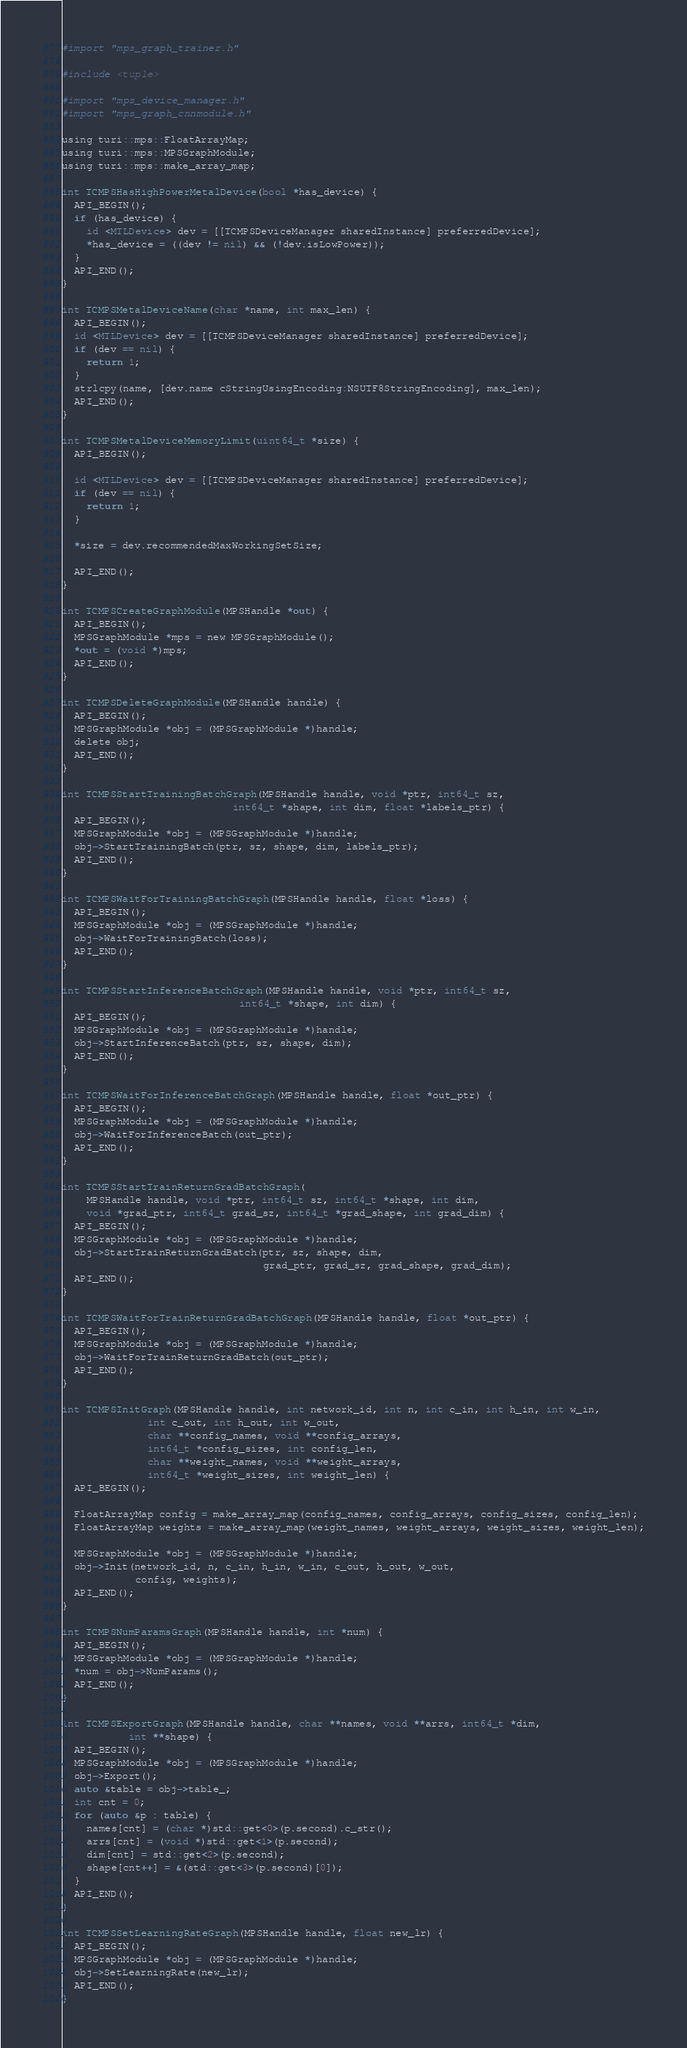Convert code to text. <code><loc_0><loc_0><loc_500><loc_500><_ObjectiveC_>#import "mps_graph_trainer.h"

#include <tuple>

#import "mps_device_manager.h"
#import "mps_graph_cnnmodule.h"

using turi::mps::FloatArrayMap;
using turi::mps::MPSGraphModule;
using turi::mps::make_array_map;

int TCMPSHasHighPowerMetalDevice(bool *has_device) {
  API_BEGIN();
  if (has_device) {
    id <MTLDevice> dev = [[TCMPSDeviceManager sharedInstance] preferredDevice];
    *has_device = ((dev != nil) && (!dev.isLowPower));
  }
  API_END();
}

int TCMPSMetalDeviceName(char *name, int max_len) {
  API_BEGIN();
  id <MTLDevice> dev = [[TCMPSDeviceManager sharedInstance] preferredDevice];
  if (dev == nil) {
    return 1;
  }
  strlcpy(name, [dev.name cStringUsingEncoding:NSUTF8StringEncoding], max_len);
  API_END();
}

int TCMPSMetalDeviceMemoryLimit(uint64_t *size) {
  API_BEGIN();

  id <MTLDevice> dev = [[TCMPSDeviceManager sharedInstance] preferredDevice];
  if (dev == nil) {
    return 1;
  }

  *size = dev.recommendedMaxWorkingSetSize;

  API_END();
}

int TCMPSCreateGraphModule(MPSHandle *out) {
  API_BEGIN();
  MPSGraphModule *mps = new MPSGraphModule();
  *out = (void *)mps;
  API_END();
}

int TCMPSDeleteGraphModule(MPSHandle handle) {
  API_BEGIN();
  MPSGraphModule *obj = (MPSGraphModule *)handle;
  delete obj;
  API_END();
}

int TCMPSStartTrainingBatchGraph(MPSHandle handle, void *ptr, int64_t sz,
                            int64_t *shape, int dim, float *labels_ptr) {
  API_BEGIN();
  MPSGraphModule *obj = (MPSGraphModule *)handle;
  obj->StartTrainingBatch(ptr, sz, shape, dim, labels_ptr);
  API_END();
}

int TCMPSWaitForTrainingBatchGraph(MPSHandle handle, float *loss) {
  API_BEGIN();
  MPSGraphModule *obj = (MPSGraphModule *)handle;
  obj->WaitForTrainingBatch(loss);
  API_END();
}

int TCMPSStartInferenceBatchGraph(MPSHandle handle, void *ptr, int64_t sz,
                             int64_t *shape, int dim) {
  API_BEGIN();
  MPSGraphModule *obj = (MPSGraphModule *)handle;
  obj->StartInferenceBatch(ptr, sz, shape, dim);
  API_END();
}

int TCMPSWaitForInferenceBatchGraph(MPSHandle handle, float *out_ptr) {
  API_BEGIN();
  MPSGraphModule *obj = (MPSGraphModule *)handle;
  obj->WaitForInferenceBatch(out_ptr);
  API_END();
}

int TCMPSStartTrainReturnGradBatchGraph(
    MPSHandle handle, void *ptr, int64_t sz, int64_t *shape, int dim,
    void *grad_ptr, int64_t grad_sz, int64_t *grad_shape, int grad_dim) {
  API_BEGIN();
  MPSGraphModule *obj = (MPSGraphModule *)handle;
  obj->StartTrainReturnGradBatch(ptr, sz, shape, dim,
                                 grad_ptr, grad_sz, grad_shape, grad_dim);
  API_END();
}

int TCMPSWaitForTrainReturnGradBatchGraph(MPSHandle handle, float *out_ptr) {
  API_BEGIN();
  MPSGraphModule *obj = (MPSGraphModule *)handle;
  obj->WaitForTrainReturnGradBatch(out_ptr);
  API_END();
}

int TCMPSInitGraph(MPSHandle handle, int network_id, int n, int c_in, int h_in, int w_in,
              int c_out, int h_out, int w_out,
              char **config_names, void **config_arrays,
              int64_t *config_sizes, int config_len,
              char **weight_names, void **weight_arrays,
              int64_t *weight_sizes, int weight_len) {
  API_BEGIN();
  
  FloatArrayMap config = make_array_map(config_names, config_arrays, config_sizes, config_len);
  FloatArrayMap weights = make_array_map(weight_names, weight_arrays, weight_sizes, weight_len);

  MPSGraphModule *obj = (MPSGraphModule *)handle;
  obj->Init(network_id, n, c_in, h_in, w_in, c_out, h_out, w_out,
            config, weights);
  API_END();
}

int TCMPSNumParamsGraph(MPSHandle handle, int *num) {
  API_BEGIN();
  MPSGraphModule *obj = (MPSGraphModule *)handle;
  *num = obj->NumParams();
  API_END();
}

int TCMPSExportGraph(MPSHandle handle, char **names, void **arrs, int64_t *dim,
           int **shape) {
  API_BEGIN();
  MPSGraphModule *obj = (MPSGraphModule *)handle;
  obj->Export();
  auto &table = obj->table_;
  int cnt = 0;
  for (auto &p : table) {
    names[cnt] = (char *)std::get<0>(p.second).c_str();
    arrs[cnt] = (void *)std::get<1>(p.second);
    dim[cnt] = std::get<2>(p.second);
    shape[cnt++] = &(std::get<3>(p.second)[0]);
  }
  API_END();
}

int TCMPSSetLearningRateGraph(MPSHandle handle, float new_lr) {
  API_BEGIN();
  MPSGraphModule *obj = (MPSGraphModule *)handle;
  obj->SetLearningRate(new_lr);
  API_END();
}
</code> 